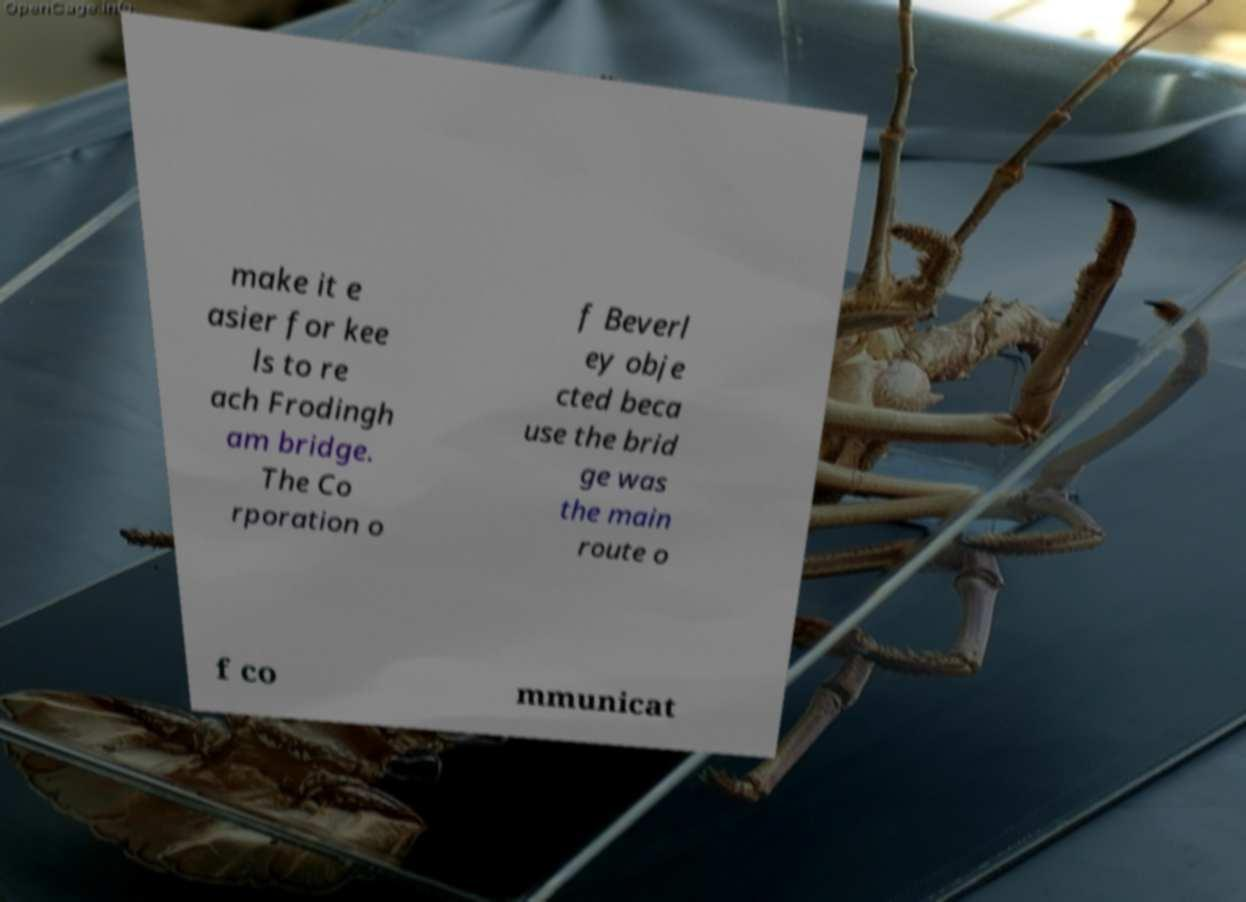What messages or text are displayed in this image? I need them in a readable, typed format. make it e asier for kee ls to re ach Frodingh am bridge. The Co rporation o f Beverl ey obje cted beca use the brid ge was the main route o f co mmunicat 